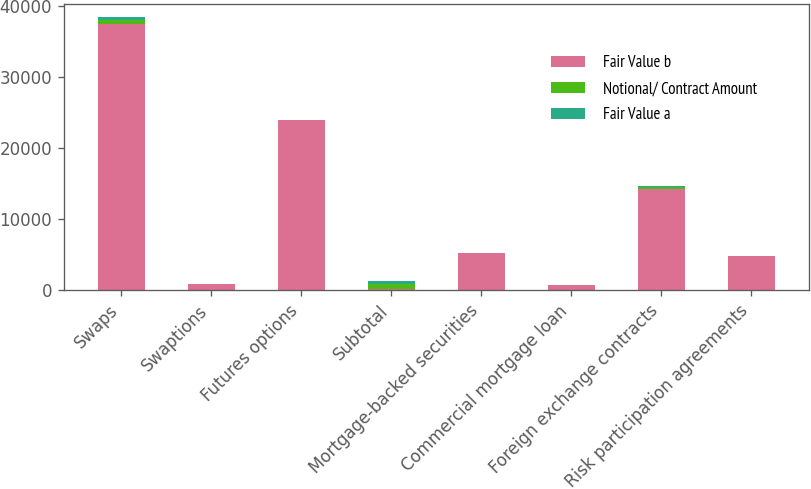Convert chart. <chart><loc_0><loc_0><loc_500><loc_500><stacked_bar_chart><ecel><fcel>Swaps<fcel>Swaptions<fcel>Futures options<fcel>Subtotal<fcel>Mortgage-backed securities<fcel>Commercial mortgage loan<fcel>Foreign exchange contracts<fcel>Risk participation agreements<nl><fcel>Fair Value b<fcel>37424<fcel>845<fcel>24000<fcel>192<fcel>5173<fcel>673<fcel>14316<fcel>4777<nl><fcel>Notional/ Contract Amount<fcel>654<fcel>18<fcel>10<fcel>682<fcel>26<fcel>20<fcel>192<fcel>2<nl><fcel>Fair Value a<fcel>360<fcel>18<fcel>2<fcel>383<fcel>9<fcel>11<fcel>172<fcel>4<nl></chart> 